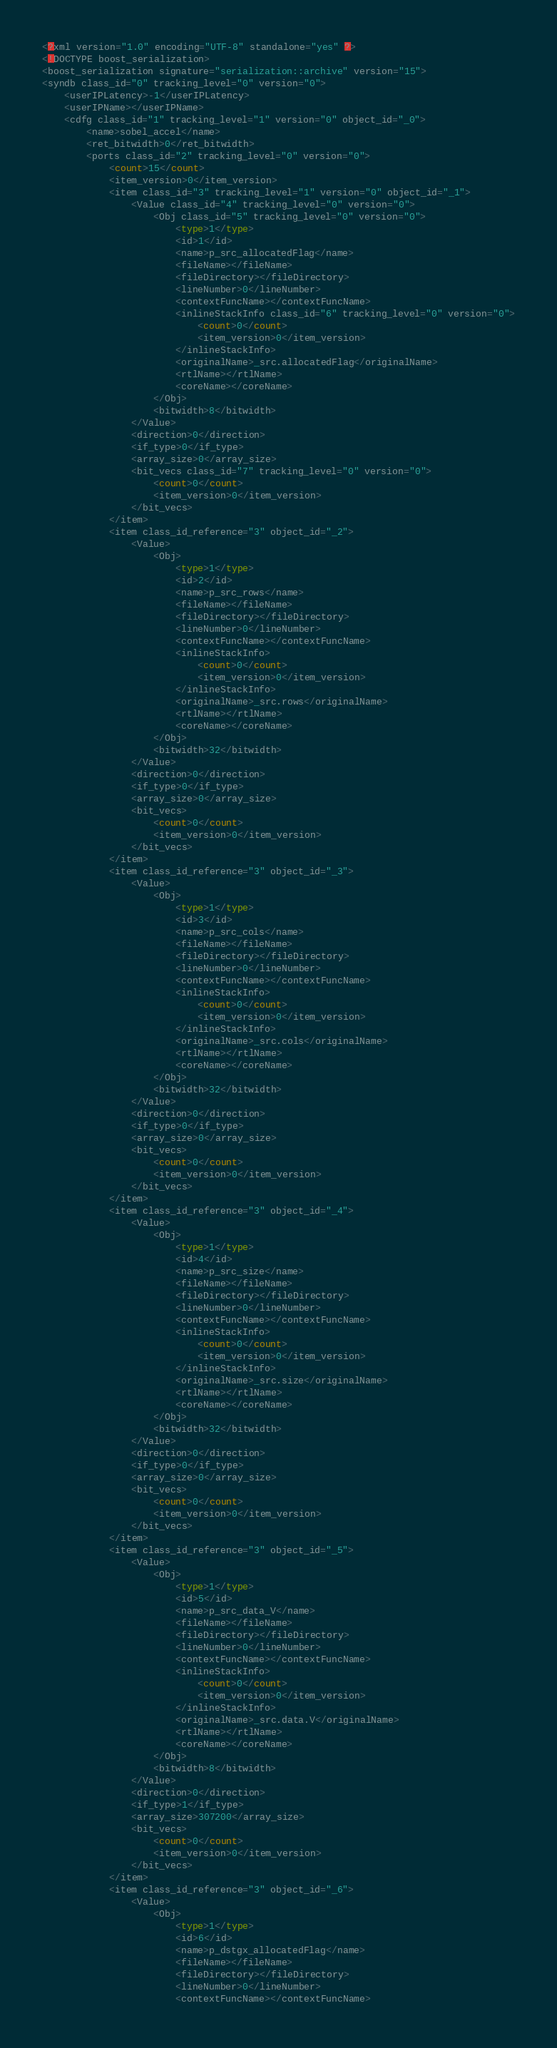<code> <loc_0><loc_0><loc_500><loc_500><_Ada_><?xml version="1.0" encoding="UTF-8" standalone="yes" ?>
<!DOCTYPE boost_serialization>
<boost_serialization signature="serialization::archive" version="15">
<syndb class_id="0" tracking_level="0" version="0">
	<userIPLatency>-1</userIPLatency>
	<userIPName></userIPName>
	<cdfg class_id="1" tracking_level="1" version="0" object_id="_0">
		<name>sobel_accel</name>
		<ret_bitwidth>0</ret_bitwidth>
		<ports class_id="2" tracking_level="0" version="0">
			<count>15</count>
			<item_version>0</item_version>
			<item class_id="3" tracking_level="1" version="0" object_id="_1">
				<Value class_id="4" tracking_level="0" version="0">
					<Obj class_id="5" tracking_level="0" version="0">
						<type>1</type>
						<id>1</id>
						<name>p_src_allocatedFlag</name>
						<fileName></fileName>
						<fileDirectory></fileDirectory>
						<lineNumber>0</lineNumber>
						<contextFuncName></contextFuncName>
						<inlineStackInfo class_id="6" tracking_level="0" version="0">
							<count>0</count>
							<item_version>0</item_version>
						</inlineStackInfo>
						<originalName>_src.allocatedFlag</originalName>
						<rtlName></rtlName>
						<coreName></coreName>
					</Obj>
					<bitwidth>8</bitwidth>
				</Value>
				<direction>0</direction>
				<if_type>0</if_type>
				<array_size>0</array_size>
				<bit_vecs class_id="7" tracking_level="0" version="0">
					<count>0</count>
					<item_version>0</item_version>
				</bit_vecs>
			</item>
			<item class_id_reference="3" object_id="_2">
				<Value>
					<Obj>
						<type>1</type>
						<id>2</id>
						<name>p_src_rows</name>
						<fileName></fileName>
						<fileDirectory></fileDirectory>
						<lineNumber>0</lineNumber>
						<contextFuncName></contextFuncName>
						<inlineStackInfo>
							<count>0</count>
							<item_version>0</item_version>
						</inlineStackInfo>
						<originalName>_src.rows</originalName>
						<rtlName></rtlName>
						<coreName></coreName>
					</Obj>
					<bitwidth>32</bitwidth>
				</Value>
				<direction>0</direction>
				<if_type>0</if_type>
				<array_size>0</array_size>
				<bit_vecs>
					<count>0</count>
					<item_version>0</item_version>
				</bit_vecs>
			</item>
			<item class_id_reference="3" object_id="_3">
				<Value>
					<Obj>
						<type>1</type>
						<id>3</id>
						<name>p_src_cols</name>
						<fileName></fileName>
						<fileDirectory></fileDirectory>
						<lineNumber>0</lineNumber>
						<contextFuncName></contextFuncName>
						<inlineStackInfo>
							<count>0</count>
							<item_version>0</item_version>
						</inlineStackInfo>
						<originalName>_src.cols</originalName>
						<rtlName></rtlName>
						<coreName></coreName>
					</Obj>
					<bitwidth>32</bitwidth>
				</Value>
				<direction>0</direction>
				<if_type>0</if_type>
				<array_size>0</array_size>
				<bit_vecs>
					<count>0</count>
					<item_version>0</item_version>
				</bit_vecs>
			</item>
			<item class_id_reference="3" object_id="_4">
				<Value>
					<Obj>
						<type>1</type>
						<id>4</id>
						<name>p_src_size</name>
						<fileName></fileName>
						<fileDirectory></fileDirectory>
						<lineNumber>0</lineNumber>
						<contextFuncName></contextFuncName>
						<inlineStackInfo>
							<count>0</count>
							<item_version>0</item_version>
						</inlineStackInfo>
						<originalName>_src.size</originalName>
						<rtlName></rtlName>
						<coreName></coreName>
					</Obj>
					<bitwidth>32</bitwidth>
				</Value>
				<direction>0</direction>
				<if_type>0</if_type>
				<array_size>0</array_size>
				<bit_vecs>
					<count>0</count>
					<item_version>0</item_version>
				</bit_vecs>
			</item>
			<item class_id_reference="3" object_id="_5">
				<Value>
					<Obj>
						<type>1</type>
						<id>5</id>
						<name>p_src_data_V</name>
						<fileName></fileName>
						<fileDirectory></fileDirectory>
						<lineNumber>0</lineNumber>
						<contextFuncName></contextFuncName>
						<inlineStackInfo>
							<count>0</count>
							<item_version>0</item_version>
						</inlineStackInfo>
						<originalName>_src.data.V</originalName>
						<rtlName></rtlName>
						<coreName></coreName>
					</Obj>
					<bitwidth>8</bitwidth>
				</Value>
				<direction>0</direction>
				<if_type>1</if_type>
				<array_size>307200</array_size>
				<bit_vecs>
					<count>0</count>
					<item_version>0</item_version>
				</bit_vecs>
			</item>
			<item class_id_reference="3" object_id="_6">
				<Value>
					<Obj>
						<type>1</type>
						<id>6</id>
						<name>p_dstgx_allocatedFlag</name>
						<fileName></fileName>
						<fileDirectory></fileDirectory>
						<lineNumber>0</lineNumber>
						<contextFuncName></contextFuncName></code> 